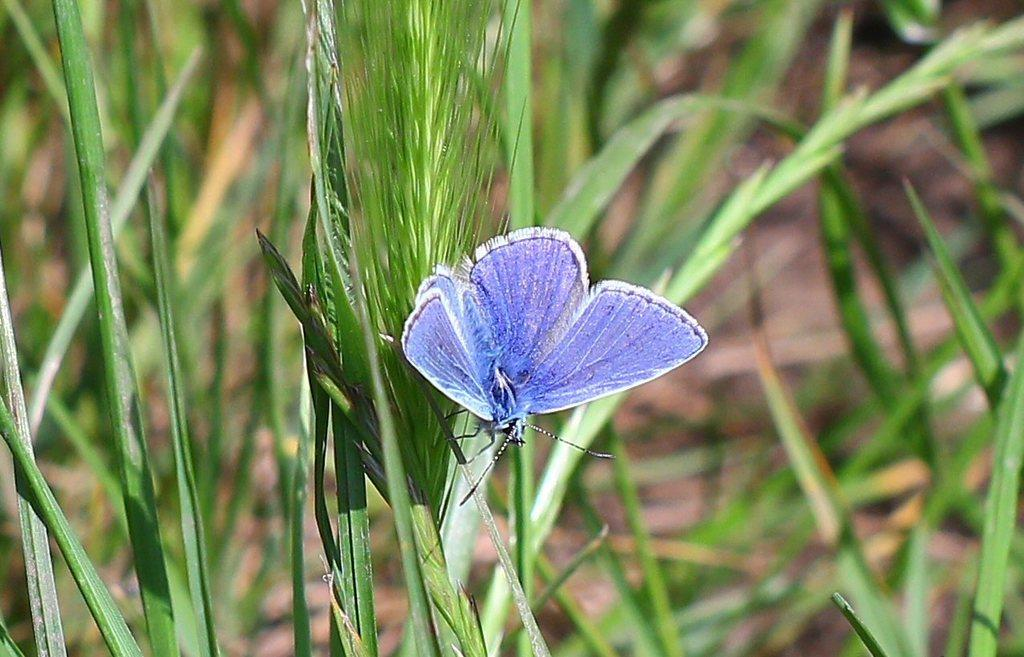What type of insect is present in the image? There is a blue color butterfly in the image. What is the butterfly sitting on? The butterfly is sitting on green color grass. Can you describe the background details be seen clearly in the image? No, the background of the image is blurred. What type of crate is visible in the image? There is no crate present in the image. Can you see any fingers holding the butterfly in the image? No, there are no fingers holding the butterfly in the image; it is sitting on the grass. 